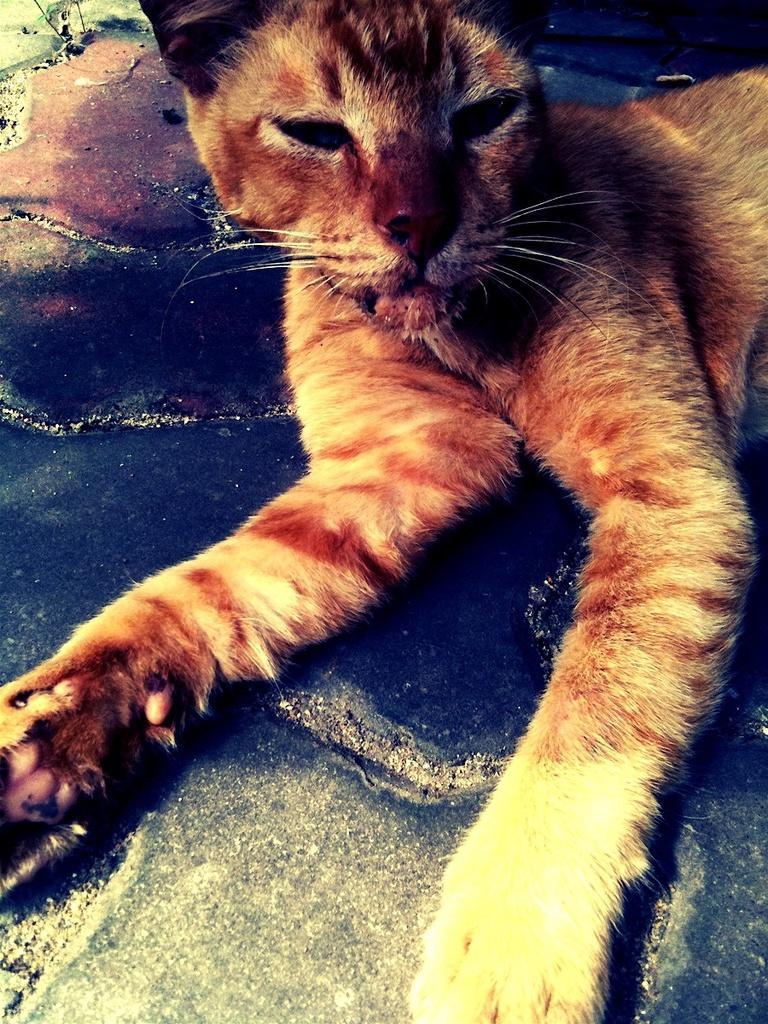In one or two sentences, can you explain what this image depicts? It's a cat on the floor which is in brown color. 